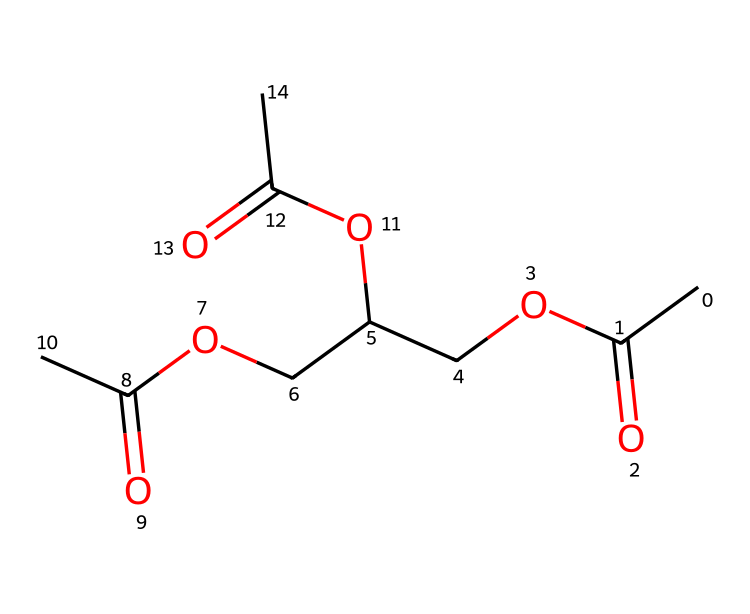How many carbon atoms are in triacetin? By examining the SMILES representation, we can count the carbon (C) atoms. The structure CC(=O)OCC(COC(=O)C)OC(=O)C indicates 9 carbon atoms in total.
Answer: 9 What is the main functional group present in triacetin? The structure shows a series of ester linkages (indicated by the -COO- groups) throughout the molecule, which is characteristic of esters.
Answer: ester How many ester functional groups does triacetin contain? Analyzing the structure shows there are three -COO- groups present in the structure, confirming the presence of three ester functional groups.
Answer: 3 What is the molecular formula of triacetin? By interpreting the SMILES, we can derive the molecular formula with 9 carbons, 14 hydrogens, and 6 oxygens, leading to the formula C9H14O6.
Answer: C9H14O6 Does triacetin have any double bonds? The provided SMILES does not denote any double bonds between carbon atoms, as all carbon atoms are connected by single bonds. The only double bonds in the structure are part of the carbonyls, which are not carbon-carbon double bonds.
Answer: no What is the role of triacetin when used as a plasticizer? Triacetin is used as a plasticizer due to its ability to increase flexibility and workability of polymeric compounds, thus making historical documents more pliable.
Answer: plasticizer 